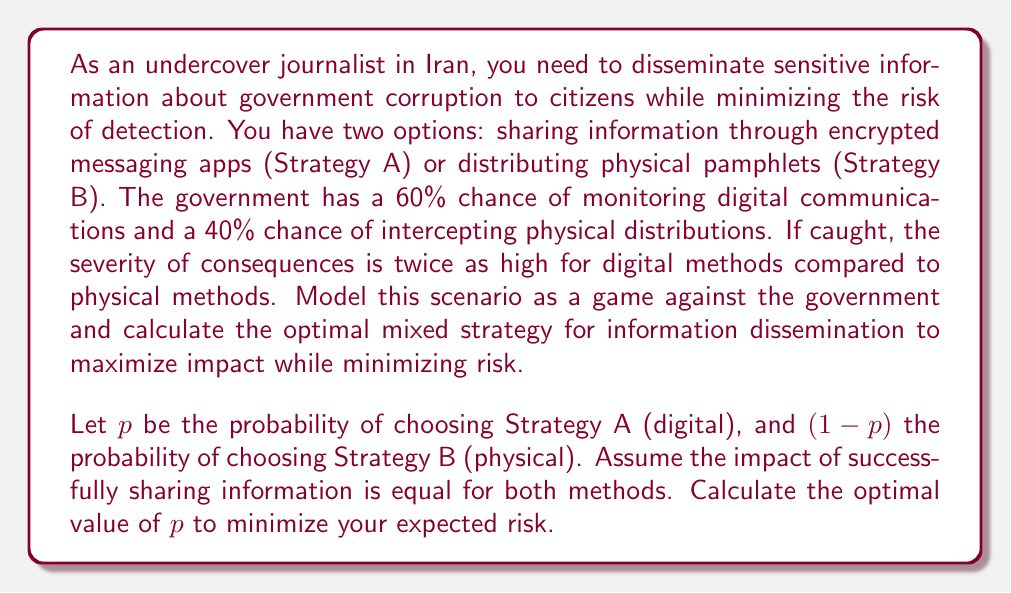Solve this math problem. To solve this problem, we'll use the principles of game theory to find the optimal mixed strategy.

1. Define the payoff matrix:
   Let's assign a risk value of 2 for digital methods if caught, and 1 for physical methods if caught.
   
   $$\begin{array}{c|cc}
   & \text{Govt Monitors} & \text{Govt Doesn't Monitor} \\
   \hline
   \text{Digital (A)} & -2 & 1 \\
   \text{Physical (B)} & -1 & 1
   \end{array}$$

2. Calculate expected payoffs:
   For Strategy A: $E(A) = 0.6(-2) + 0.4(1) = -0.8$
   For Strategy B: $E(B) = 0.4(-1) + 0.6(1) = 0.2$

3. Set up the equation for mixed strategy:
   We want to find $p$ such that the expected payoff of choosing A with probability $p$ and B with probability $(1-p)$ is equal:
   
   $$p(-0.8) + (1-p)(0.2) = 0$$

4. Solve for $p$:
   $$-0.8p + 0.2 - 0.2p = 0$$
   $$-p + 0.2 = 0$$
   $$p = 0.2$$

5. Verify the result:
   With $p = 0.2$, the expected payoff is:
   $$0.2(-0.8) + 0.8(0.2) = -0.16 + 0.16 = 0$$

   This confirms that the strategy is optimal, as it equalizes the expected payoffs for both pure strategies.

Therefore, the optimal mixed strategy is to use digital methods (Strategy A) 20% of the time and physical methods (Strategy B) 80% of the time.
Answer: The optimal mixed strategy is to use digital methods (Strategy A) with probability $p = 0.2$ and physical methods (Strategy B) with probability $1-p = 0.8$. 